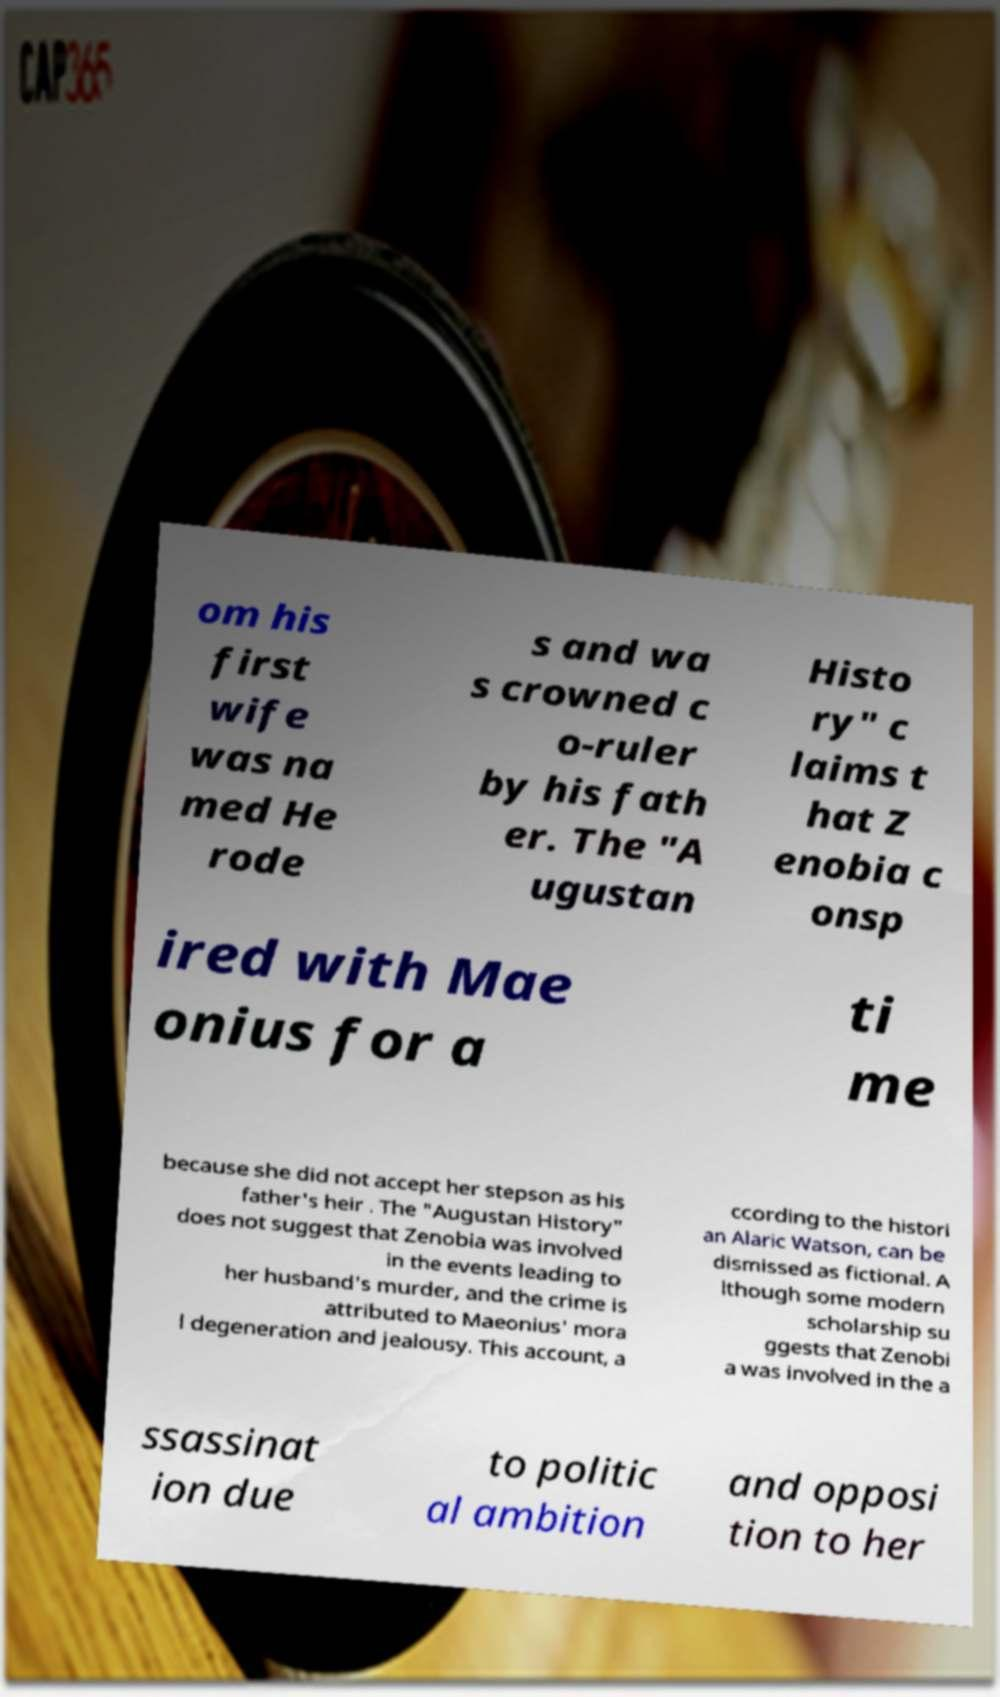For documentation purposes, I need the text within this image transcribed. Could you provide that? om his first wife was na med He rode s and wa s crowned c o-ruler by his fath er. The "A ugustan Histo ry" c laims t hat Z enobia c onsp ired with Mae onius for a ti me because she did not accept her stepson as his father's heir . The "Augustan History" does not suggest that Zenobia was involved in the events leading to her husband's murder, and the crime is attributed to Maeonius' mora l degeneration and jealousy. This account, a ccording to the histori an Alaric Watson, can be dismissed as fictional. A lthough some modern scholarship su ggests that Zenobi a was involved in the a ssassinat ion due to politic al ambition and opposi tion to her 